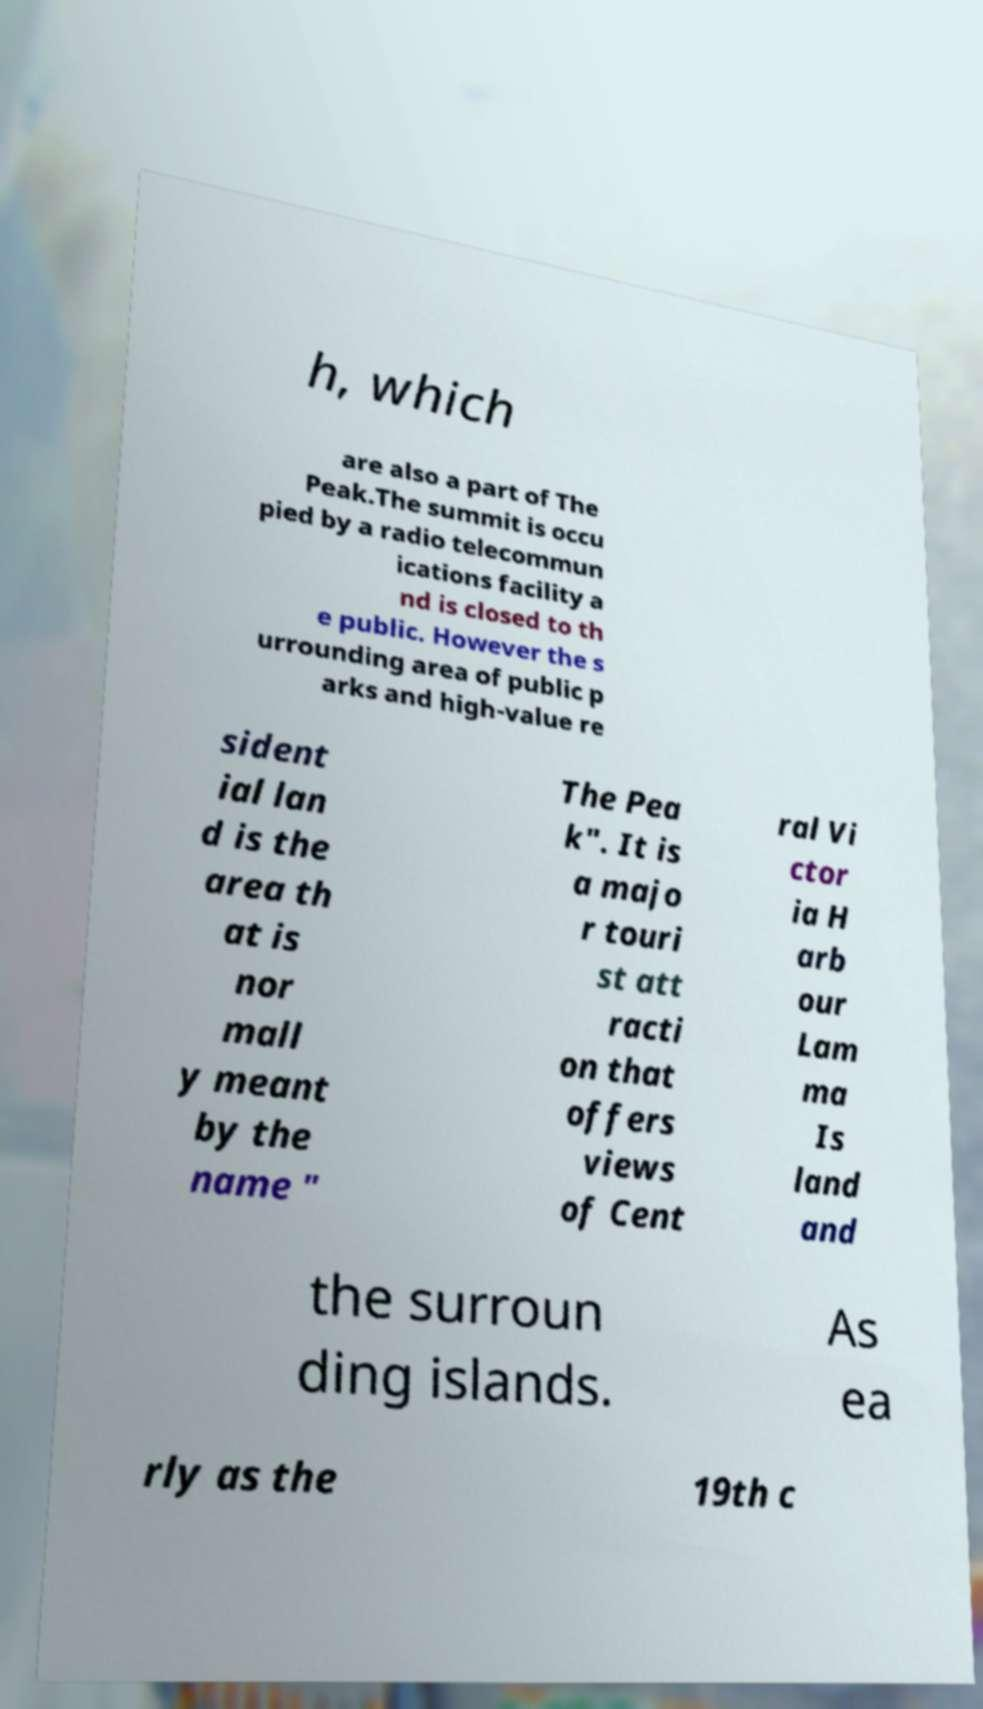Could you extract and type out the text from this image? h, which are also a part of The Peak.The summit is occu pied by a radio telecommun ications facility a nd is closed to th e public. However the s urrounding area of public p arks and high-value re sident ial lan d is the area th at is nor mall y meant by the name " The Pea k". It is a majo r touri st att racti on that offers views of Cent ral Vi ctor ia H arb our Lam ma Is land and the surroun ding islands. As ea rly as the 19th c 